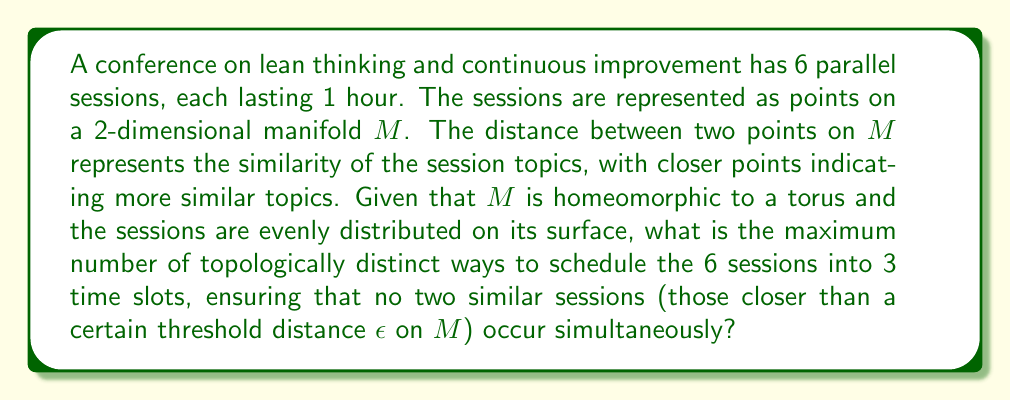Teach me how to tackle this problem. To solve this problem, we need to consider the topological properties of the torus and how the sessions are distributed on its surface. Let's approach this step-by-step:

1) The torus is a 2-dimensional manifold with genus 1. It can be represented as the quotient space of a rectangle where opposite edges are identified.

2) Since the sessions are evenly distributed on the surface of the torus, we can imagine them as 6 points spread out on this rectangular representation.

3) The similarity threshold $\epsilon$ creates a neighborhood around each point. Sessions within this neighborhood are considered too similar to be scheduled simultaneously.

4) To schedule the sessions, we need to partition the 6 points into 3 sets of 2 points each, where no two points in the same set are within $\epsilon$ distance of each other.

5) The number of topologically distinct ways to do this depends on how the $\epsilon$-neighborhoods of the points intersect on the surface of the torus.

6) In the most general case, assuming the $\epsilon$ is small enough, each point could be paired with any of the 5 other points that are not within its $\epsilon$-neighborhood.

7) However, some of these pairings might be topologically equivalent due to the symmetries of the torus.

8) The fundamental group of the torus is $\mathbb{Z} \times \mathbb{Z}$, which gives rise to translation symmetries in both directions of the rectangular representation.

9) Taking these symmetries into account, we can deduce that there are at most 3 topologically distinct ways to pair the points:
   - Pairing along one direction of the torus
   - Pairing along the other direction of the torus
   - Pairing along the diagonal of the torus

10) Each of these 3 ways of pairing determines a unique way to schedule the 6 sessions into 3 time slots.

Therefore, the maximum number of topologically distinct ways to schedule the sessions is 3.
Answer: 3 topologically distinct scheduling arrangements 